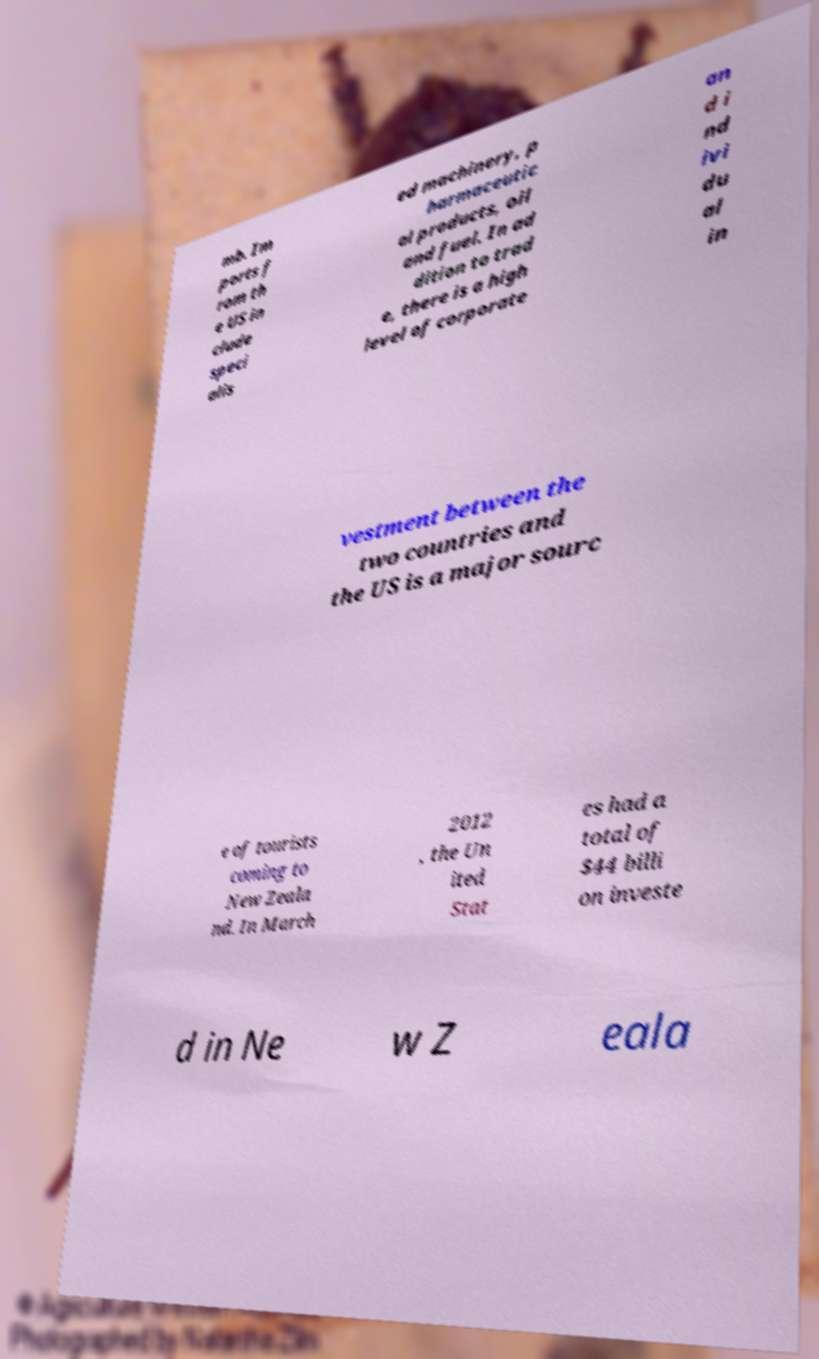Could you extract and type out the text from this image? mb. Im ports f rom th e US in clude speci alis ed machinery, p harmaceutic al products, oil and fuel. In ad dition to trad e, there is a high level of corporate an d i nd ivi du al in vestment between the two countries and the US is a major sourc e of tourists coming to New Zeala nd. In March 2012 , the Un ited Stat es had a total of $44 billi on investe d in Ne w Z eala 